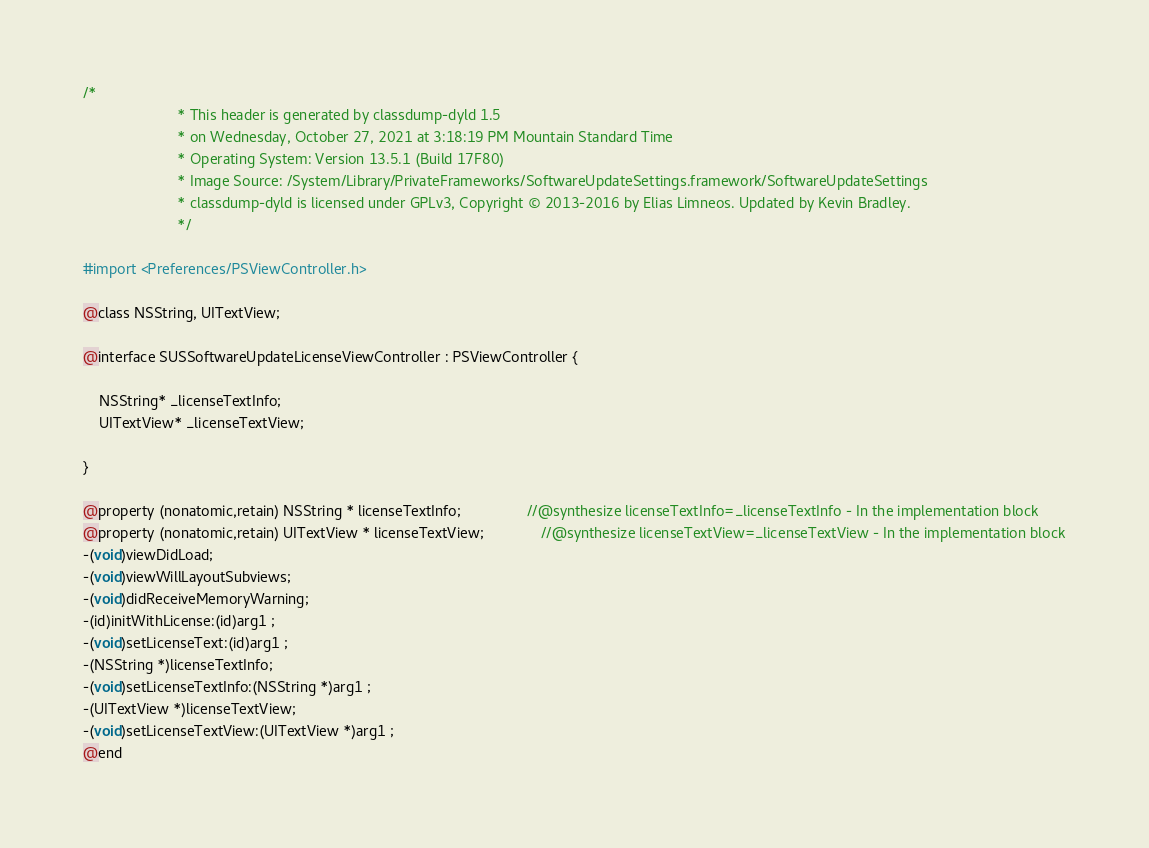Convert code to text. <code><loc_0><loc_0><loc_500><loc_500><_C_>/*
                       * This header is generated by classdump-dyld 1.5
                       * on Wednesday, October 27, 2021 at 3:18:19 PM Mountain Standard Time
                       * Operating System: Version 13.5.1 (Build 17F80)
                       * Image Source: /System/Library/PrivateFrameworks/SoftwareUpdateSettings.framework/SoftwareUpdateSettings
                       * classdump-dyld is licensed under GPLv3, Copyright © 2013-2016 by Elias Limneos. Updated by Kevin Bradley.
                       */

#import <Preferences/PSViewController.h>

@class NSString, UITextView;

@interface SUSSoftwareUpdateLicenseViewController : PSViewController {

	NSString* _licenseTextInfo;
	UITextView* _licenseTextView;

}

@property (nonatomic,retain) NSString * licenseTextInfo;                //@synthesize licenseTextInfo=_licenseTextInfo - In the implementation block
@property (nonatomic,retain) UITextView * licenseTextView;              //@synthesize licenseTextView=_licenseTextView - In the implementation block
-(void)viewDidLoad;
-(void)viewWillLayoutSubviews;
-(void)didReceiveMemoryWarning;
-(id)initWithLicense:(id)arg1 ;
-(void)setLicenseText:(id)arg1 ;
-(NSString *)licenseTextInfo;
-(void)setLicenseTextInfo:(NSString *)arg1 ;
-(UITextView *)licenseTextView;
-(void)setLicenseTextView:(UITextView *)arg1 ;
@end

</code> 